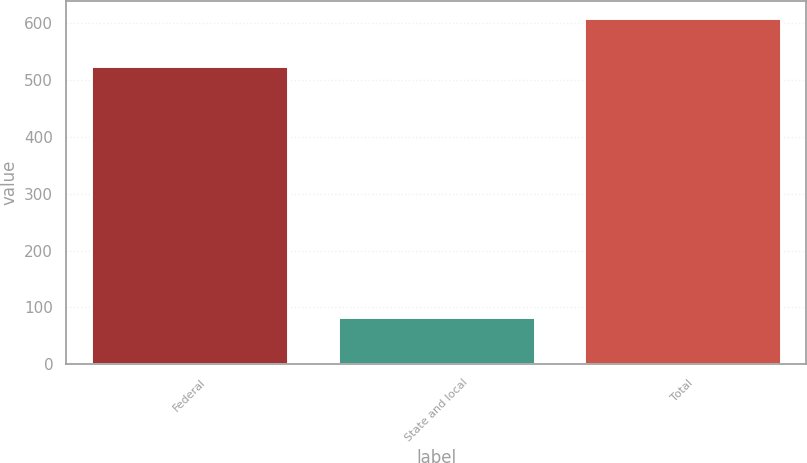<chart> <loc_0><loc_0><loc_500><loc_500><bar_chart><fcel>Federal<fcel>State and local<fcel>Total<nl><fcel>525<fcel>84<fcel>609<nl></chart> 